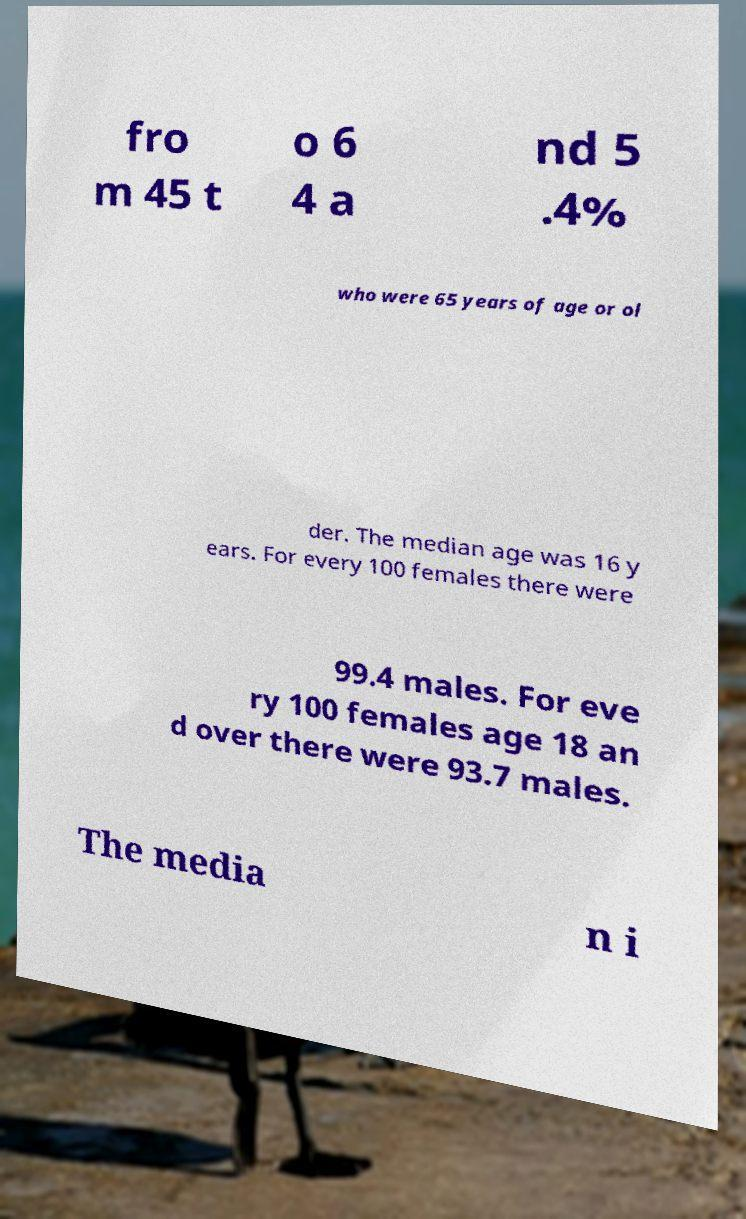There's text embedded in this image that I need extracted. Can you transcribe it verbatim? fro m 45 t o 6 4 a nd 5 .4% who were 65 years of age or ol der. The median age was 16 y ears. For every 100 females there were 99.4 males. For eve ry 100 females age 18 an d over there were 93.7 males. The media n i 